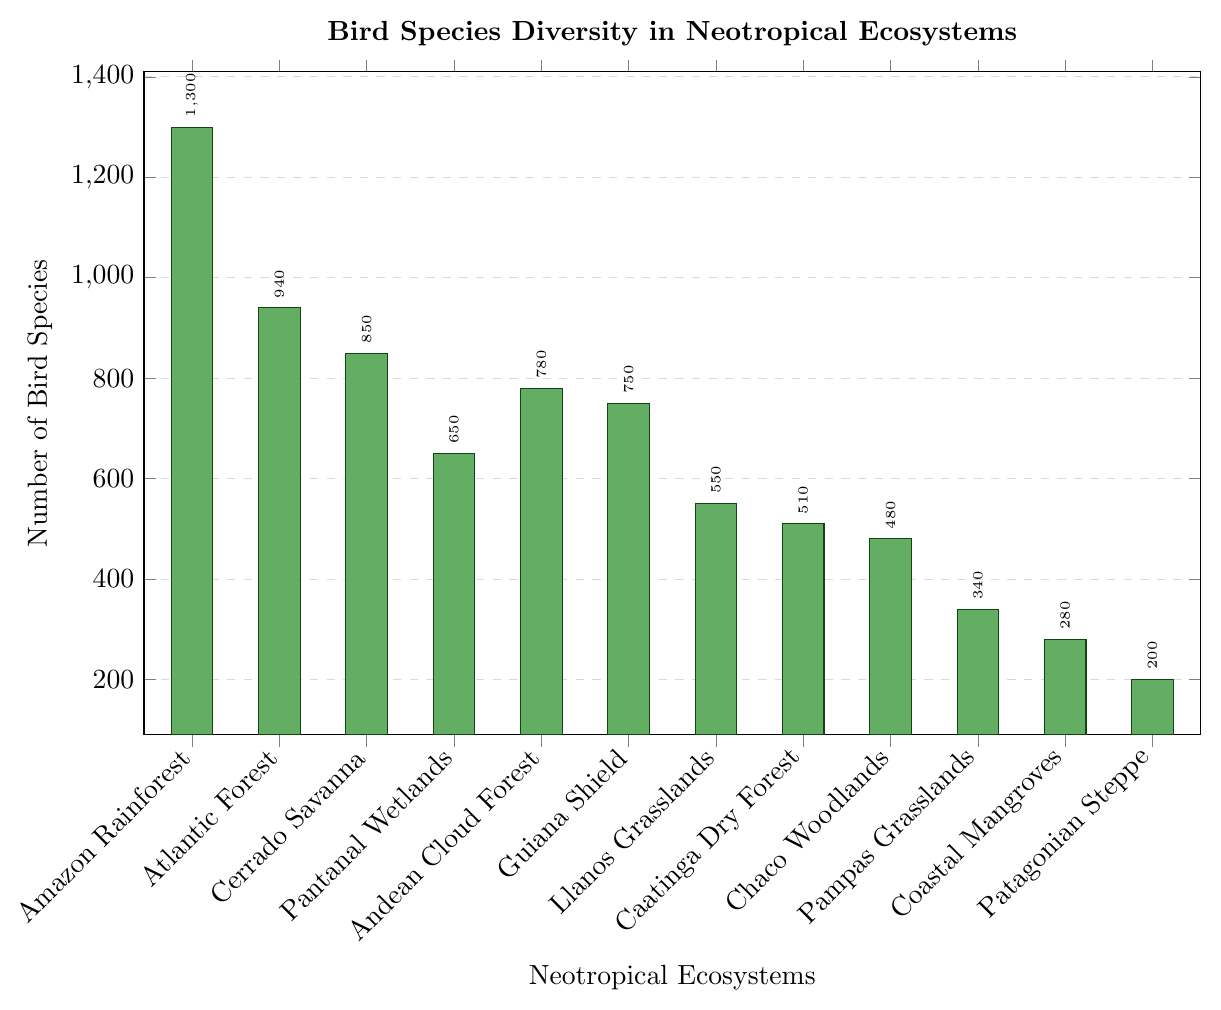What's the ecosystem with the highest bird species diversity? To determine the ecosystem with the highest bird species diversity, look for the tallest bar in the plot. The tallest bar corresponds to the Amazon Rainforest, which has a bird species diversity of 1300 species.
Answer: Amazon Rainforest Which ecosystem has fewer bird species: Caatinga Dry Forest or Chaco Woodlands? To compare the bird species diversity between Caatinga Dry Forest and Chaco Woodlands, find their respective bars in the plot and compare their heights. The Caatinga Dry Forest has a taller bar at 510 species, while the Chaco Woodlands have 480 species.
Answer: Chaco Woodlands What's the total number of bird species in the Llanos Grasslands and Pampas Grasslands combined? Find the bars representing Llanos Grasslands and Pampas Grasslands and add their values: 550 + 340 = 890.
Answer: 890 How many more bird species are there in the Guiana Shield compared to the Coastal Mangroves? Find the difference between the number of bird species in the Guiana Shield and Coastal Mangroves: 750 - 280 = 470.
Answer: 470 What is the average bird species diversity across the Amazon Rainforest, Atlantic Forest, and Cerrado Savanna? Add the bird species diversity of Amazon Rainforest (1300), Atlantic Forest (940), and Cerrado Savanna (850), then divide by 3: (1300 + 940 + 850)/3 = 1030.
Answer: 1030 Among the Pampas Grasslands, Coastal Mangroves, and Patagonian Steppe, which has the lowest bird species diversity? Look for the shortest bar among Pampas Grasslands, Coastal Mangroves, and Patagonian Steppe. The Patagonian Steppe has the shortest bar with 200 species.
Answer: Patagonian Steppe What's the difference in bird species diversity between the Pantanal Wetlands and Andean Cloud Forest? Subtract the number of bird species in the Andean Cloud Forest (780) from the Pantanal Wetlands (650): 780 - 650 = 130.
Answer: 130 By how many species does the Cerrado Savanna outnumber the Llanos Grasslands in bird species diversity? Subtract the number of bird species in Llanos Grasslands (550) from Cerrado Savanna (850): 850 - 550 = 300.
Answer: 300 What is the median bird species diversity among all listed ecosystems? First, list the numbers in ascending order: 200, 280, 340, 480, 510, 550, 650, 750, 780, 850, 940, 1300. Since there are 12 data points, the median is the average of the 6th and 7th values: (550 + 650)/2 = 600.
Answer: 600 